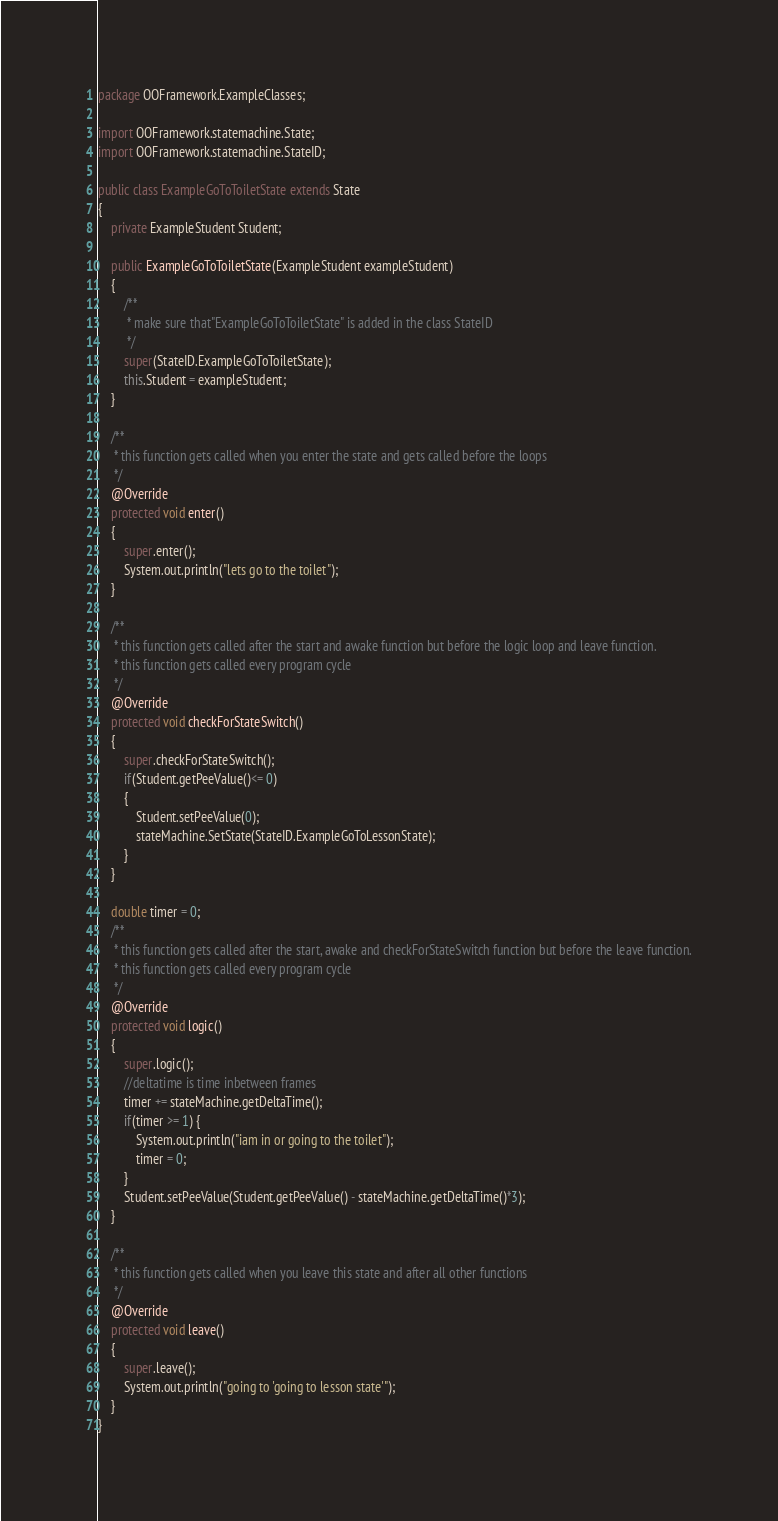Convert code to text. <code><loc_0><loc_0><loc_500><loc_500><_Java_>package OOFramework.ExampleClasses;

import OOFramework.statemachine.State;
import OOFramework.statemachine.StateID;

public class ExampleGoToToiletState extends State
{
    private ExampleStudent Student;

    public ExampleGoToToiletState(ExampleStudent exampleStudent)
    {
        /**
         * make sure that"ExampleGoToToiletState" is added in the class StateID
         */
        super(StateID.ExampleGoToToiletState);
        this.Student = exampleStudent;
    }

    /**
     * this function gets called when you enter the state and gets called before the loops
     */
    @Override
    protected void enter()
    {
        super.enter();
        System.out.println("lets go to the toilet");
    }

    /**
     * this function gets called after the start and awake function but before the logic loop and leave function.
     * this function gets called every program cycle
     */
    @Override
    protected void checkForStateSwitch()
    {
        super.checkForStateSwitch();
        if(Student.getPeeValue()<= 0)
        {
            Student.setPeeValue(0);
            stateMachine.SetState(StateID.ExampleGoToLessonState);
        }
    }

    double timer = 0;
    /**
     * this function gets called after the start, awake and checkForStateSwitch function but before the leave function.
     * this function gets called every program cycle
     */
    @Override
    protected void logic()
    {
        super.logic();
        //deltatime is time inbetween frames
        timer += stateMachine.getDeltaTime();
        if(timer >= 1) {
            System.out.println("iam in or going to the toilet");
            timer = 0;
        }
        Student.setPeeValue(Student.getPeeValue() - stateMachine.getDeltaTime()*3);
    }

    /**
     * this function gets called when you leave this state and after all other functions
     */
    @Override
    protected void leave()
    {
        super.leave();
        System.out.println("going to 'going to lesson state'");
    }
}</code> 